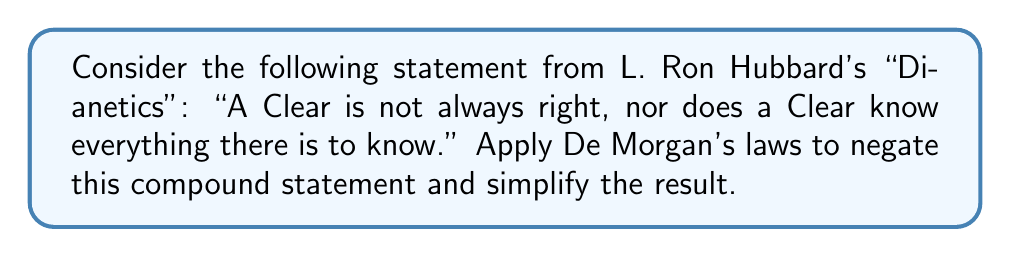Teach me how to tackle this problem. Let's approach this step-by-step:

1) First, let's define our propositions:
   $p$: A Clear is always right
   $q$: A Clear knows everything there is to know

2) The original statement can be written as: $\neg p \land \neg q$

3) To negate this statement, we apply De Morgan's first law:
   $\neg(\neg p \land \neg q)$

4) De Morgan's first law states that the negation of a conjunction is the disjunction of the negations:
   $\neg(\neg p \land \neg q) \equiv (\neg(\neg p) \lor \neg(\neg q))$

5) Simplify by applying the double negation law:
   $(\neg(\neg p) \lor \neg(\neg q)) \equiv (p \lor q)$

6) Therefore, the negation of the original statement is:
   "A Clear is always right OR a Clear knows everything there is to know."

This simplified statement represents the logical opposite of Hubbard's original assertion, using De Morgan's laws.
Answer: $p \lor q$ 